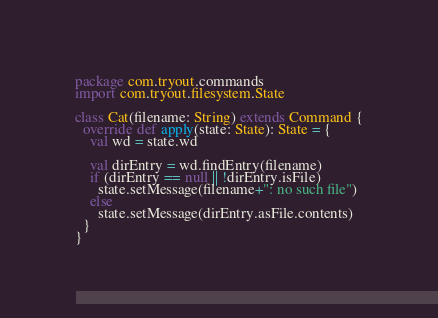Convert code to text. <code><loc_0><loc_0><loc_500><loc_500><_Scala_>package com.tryout.commands
import com.tryout.filesystem.State

class Cat(filename: String) extends Command {
  override def apply(state: State): State = {
    val wd = state.wd

    val dirEntry = wd.findEntry(filename)
    if (dirEntry == null || !dirEntry.isFile)
      state.setMessage(filename+": no such file")
    else
      state.setMessage(dirEntry.asFile.contents)
  }
}
</code> 